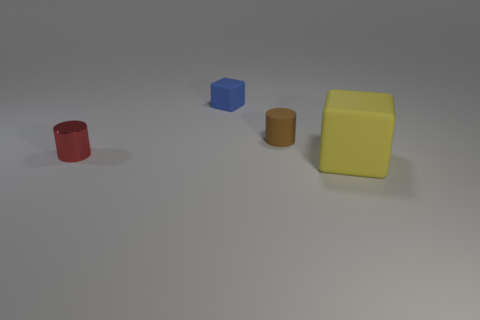Add 4 large purple metallic objects. How many objects exist? 8 Add 4 brown cylinders. How many brown cylinders exist? 5 Subtract 0 cyan cubes. How many objects are left? 4 Subtract all large gray rubber balls. Subtract all yellow cubes. How many objects are left? 3 Add 4 tiny brown objects. How many tiny brown objects are left? 5 